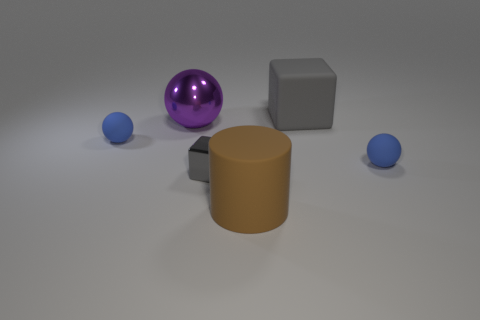Does the composition of this image suggest any particular theme or concept? The composition might suggest a theme of balance and contrast. The varying shapes and sizes of the objects, along with their placement, create a sense of equilibrium. The differences in materials—metallic, matte, and shiny surfaces—introduce a contrast of textures. 